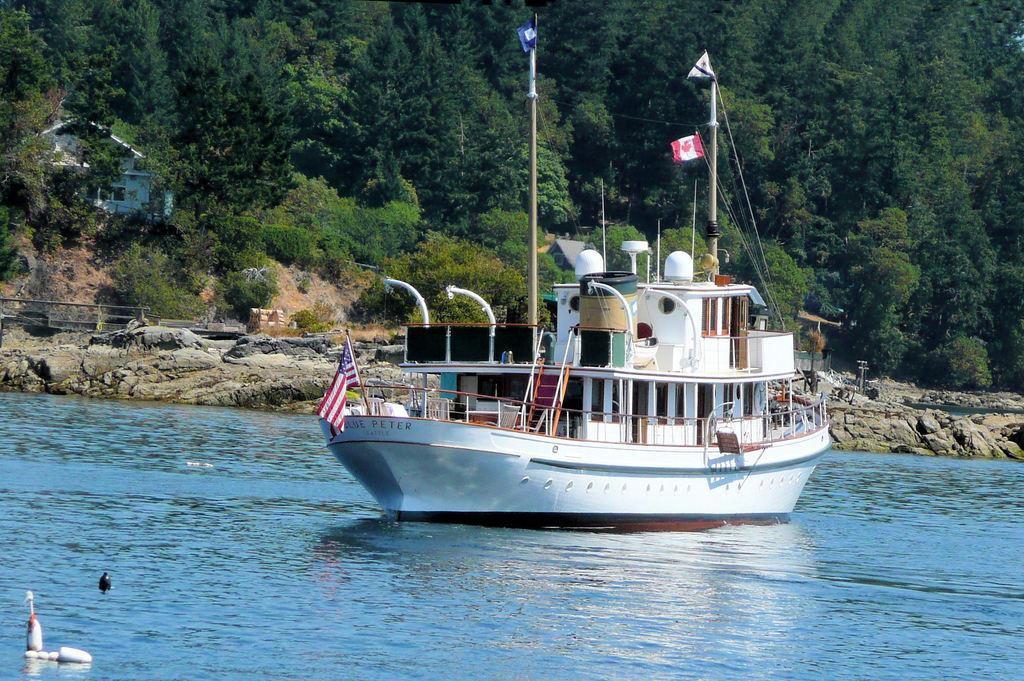<image>
Relay a brief, clear account of the picture shown. A boat on the water bears the name Blue Peter. 